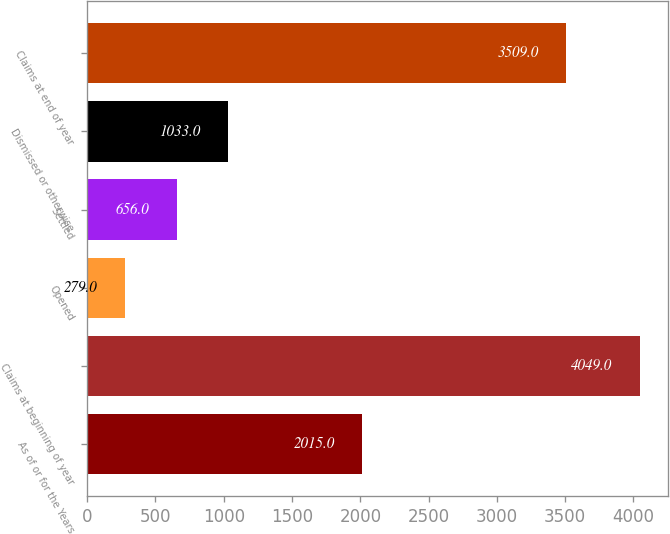<chart> <loc_0><loc_0><loc_500><loc_500><bar_chart><fcel>As of or for the Years<fcel>Claims at beginning of year<fcel>Opened<fcel>Settled<fcel>Dismissed or otherwise<fcel>Claims at end of year<nl><fcel>2015<fcel>4049<fcel>279<fcel>656<fcel>1033<fcel>3509<nl></chart> 